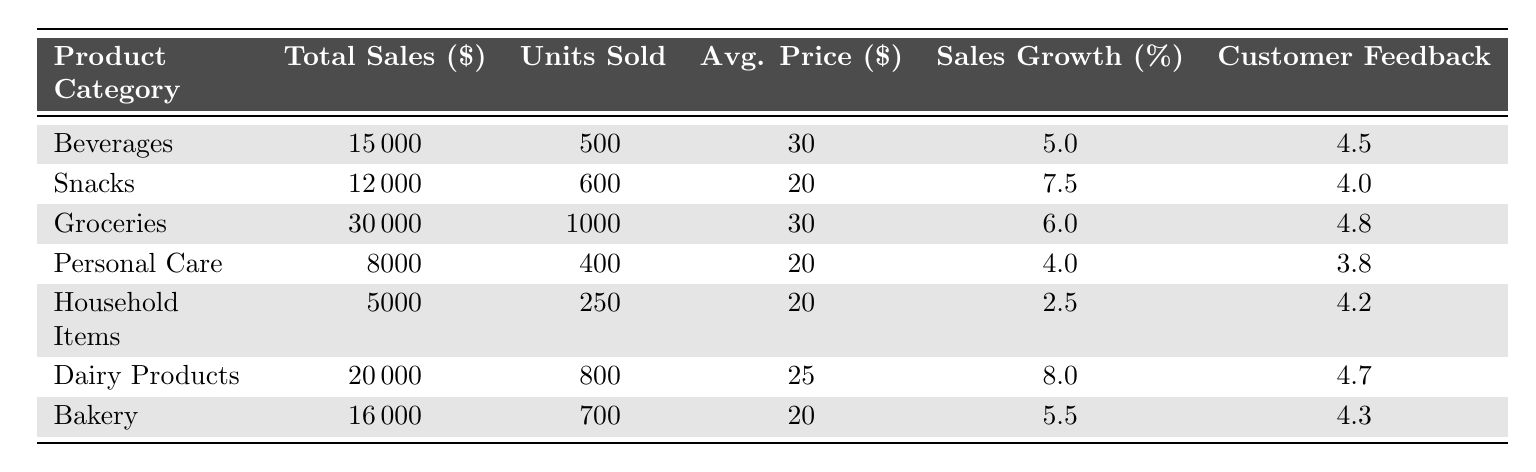What is the total sales of the Snacks category? According to the table, the value listed under the total sales for the Snacks category is 12000.
Answer: 12000 Which product category has the highest units sold? By comparing the units sold of each category, Groceries has the highest at 1000 units.
Answer: Groceries What is the average price of Dairy Products? The average price listed for Dairy Products in the table is 25.
Answer: 25 Is the customer feedback for Personal Care higher than 4.0? The customer feedback for Personal Care is 3.8, which is lower than 4.0.
Answer: No What is the sales growth rate of Bakery? The sales growth rate for Bakery is shown in the table as 5.5.
Answer: 5.5 Calculate the total sales of Groceries and Dairy Products combined. The total sales for Groceries is 30000 and for Dairy Products it is 20000. Adding these together gives 30000 + 20000 = 50000.
Answer: 50000 Which product category has the lowest customer feedback? By examining the customer feedback ratings, Personal Care has the lowest feedback score of 3.8.
Answer: Personal Care If we compare the average prices of Beverages and Snacks, which one is higher? The average price for Beverages is 30, while the average price for Snacks is 20. Since 30 is greater than 20, Beverages has a higher average price.
Answer: Beverages What percentage growth is seen in Dairy Products as compared to Household Items? The sales growth for Dairy Products is 8.0 and for Household Items is 2.5. The difference is 8.0 - 2.5 = 5.5, indicating Dairy Products has a 5.5% higher growth rate.
Answer: 5.5% If total sales of Personal Care and Household Items are calculated, what is the result? The total sales for Personal Care is 8000, and for Household Items is 5000. Adding these gives 8000 + 5000 = 13000.
Answer: 13000 